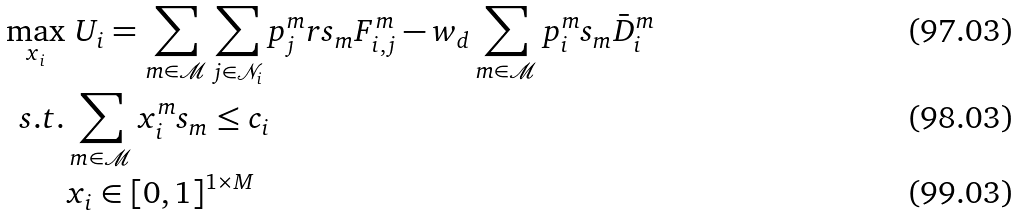Convert formula to latex. <formula><loc_0><loc_0><loc_500><loc_500>\max _ { x _ { i } } & \ U _ { i } = \sum _ { m \in \mathcal { M } } \sum _ { j \in \mathcal { N } _ { i } } p _ { j } ^ { m } r s _ { m } F _ { i , j } ^ { m } - w _ { d } \sum _ { m \in \mathcal { M } } p _ { i } ^ { m } s _ { m } \bar { D } _ { i } ^ { m } \\ s . t . & \sum _ { m \in \mathcal { M } } x _ { i } ^ { m } s _ { m } \leq c _ { i } \\ & x _ { i } \in [ 0 , 1 ] ^ { 1 \times M }</formula> 